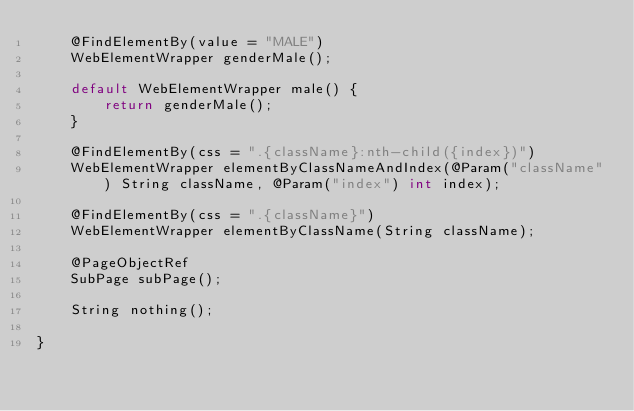<code> <loc_0><loc_0><loc_500><loc_500><_Java_>    @FindElementBy(value = "MALE")
    WebElementWrapper genderMale();

    default WebElementWrapper male() {
        return genderMale();
    }

    @FindElementBy(css = ".{className}:nth-child({index})")
    WebElementWrapper elementByClassNameAndIndex(@Param("className") String className, @Param("index") int index);

    @FindElementBy(css = ".{className}")
    WebElementWrapper elementByClassName(String className);

    @PageObjectRef
    SubPage subPage();

    String nothing();

}
</code> 